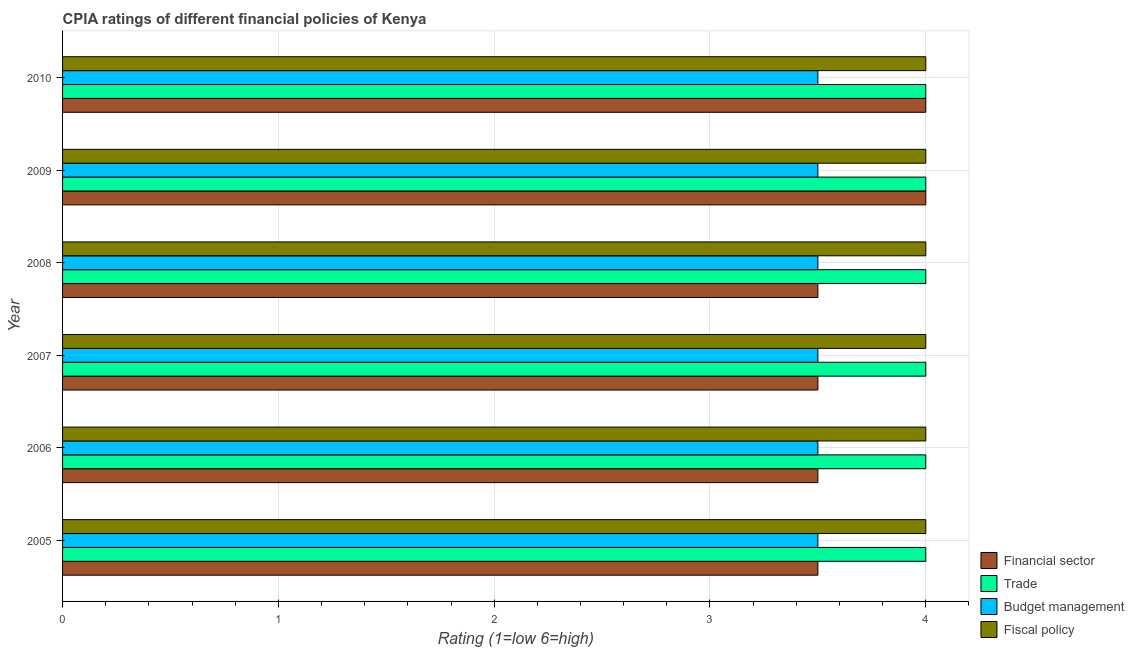How many different coloured bars are there?
Give a very brief answer. 4. Are the number of bars per tick equal to the number of legend labels?
Offer a terse response. Yes. Are the number of bars on each tick of the Y-axis equal?
Your response must be concise. Yes. In how many cases, is the number of bars for a given year not equal to the number of legend labels?
Ensure brevity in your answer.  0. What is the cpia rating of budget management in 2007?
Ensure brevity in your answer.  3.5. Across all years, what is the maximum cpia rating of trade?
Your answer should be compact. 4. Across all years, what is the minimum cpia rating of trade?
Your answer should be compact. 4. In which year was the cpia rating of fiscal policy maximum?
Give a very brief answer. 2005. In which year was the cpia rating of financial sector minimum?
Your response must be concise. 2005. What is the average cpia rating of financial sector per year?
Your answer should be compact. 3.67. What is the difference between the highest and the lowest cpia rating of trade?
Your response must be concise. 0. Is the sum of the cpia rating of budget management in 2005 and 2010 greater than the maximum cpia rating of financial sector across all years?
Offer a terse response. Yes. Is it the case that in every year, the sum of the cpia rating of trade and cpia rating of financial sector is greater than the sum of cpia rating of budget management and cpia rating of fiscal policy?
Provide a short and direct response. Yes. What does the 2nd bar from the top in 2005 represents?
Ensure brevity in your answer.  Budget management. What does the 1st bar from the bottom in 2005 represents?
Your answer should be very brief. Financial sector. Is it the case that in every year, the sum of the cpia rating of financial sector and cpia rating of trade is greater than the cpia rating of budget management?
Your answer should be very brief. Yes. How many bars are there?
Offer a terse response. 24. Are all the bars in the graph horizontal?
Ensure brevity in your answer.  Yes. What is the difference between two consecutive major ticks on the X-axis?
Offer a very short reply. 1. Does the graph contain grids?
Your response must be concise. Yes. How are the legend labels stacked?
Your answer should be very brief. Vertical. What is the title of the graph?
Provide a short and direct response. CPIA ratings of different financial policies of Kenya. Does "Building human resources" appear as one of the legend labels in the graph?
Make the answer very short. No. What is the Rating (1=low 6=high) in Financial sector in 2005?
Provide a succinct answer. 3.5. What is the Rating (1=low 6=high) in Fiscal policy in 2005?
Keep it short and to the point. 4. What is the Rating (1=low 6=high) of Financial sector in 2006?
Your answer should be compact. 3.5. What is the Rating (1=low 6=high) of Trade in 2006?
Provide a short and direct response. 4. What is the Rating (1=low 6=high) of Financial sector in 2007?
Keep it short and to the point. 3.5. What is the Rating (1=low 6=high) of Trade in 2007?
Offer a very short reply. 4. What is the Rating (1=low 6=high) in Budget management in 2007?
Keep it short and to the point. 3.5. What is the Rating (1=low 6=high) in Budget management in 2008?
Give a very brief answer. 3.5. What is the Rating (1=low 6=high) in Fiscal policy in 2008?
Make the answer very short. 4. What is the Rating (1=low 6=high) in Financial sector in 2009?
Provide a succinct answer. 4. What is the Rating (1=low 6=high) in Trade in 2009?
Provide a succinct answer. 4. What is the Rating (1=low 6=high) in Trade in 2010?
Keep it short and to the point. 4. What is the Rating (1=low 6=high) of Fiscal policy in 2010?
Your answer should be very brief. 4. Across all years, what is the maximum Rating (1=low 6=high) in Financial sector?
Provide a succinct answer. 4. Across all years, what is the maximum Rating (1=low 6=high) in Trade?
Ensure brevity in your answer.  4. Across all years, what is the minimum Rating (1=low 6=high) of Trade?
Offer a terse response. 4. What is the total Rating (1=low 6=high) of Financial sector in the graph?
Offer a very short reply. 22. What is the total Rating (1=low 6=high) of Trade in the graph?
Your response must be concise. 24. What is the total Rating (1=low 6=high) in Fiscal policy in the graph?
Make the answer very short. 24. What is the difference between the Rating (1=low 6=high) of Financial sector in 2005 and that in 2006?
Your response must be concise. 0. What is the difference between the Rating (1=low 6=high) of Financial sector in 2005 and that in 2007?
Offer a very short reply. 0. What is the difference between the Rating (1=low 6=high) of Trade in 2005 and that in 2007?
Make the answer very short. 0. What is the difference between the Rating (1=low 6=high) in Budget management in 2005 and that in 2007?
Your response must be concise. 0. What is the difference between the Rating (1=low 6=high) of Fiscal policy in 2005 and that in 2007?
Provide a short and direct response. 0. What is the difference between the Rating (1=low 6=high) in Budget management in 2005 and that in 2008?
Your answer should be very brief. 0. What is the difference between the Rating (1=low 6=high) of Fiscal policy in 2005 and that in 2008?
Give a very brief answer. 0. What is the difference between the Rating (1=low 6=high) of Financial sector in 2005 and that in 2009?
Give a very brief answer. -0.5. What is the difference between the Rating (1=low 6=high) in Trade in 2005 and that in 2009?
Give a very brief answer. 0. What is the difference between the Rating (1=low 6=high) of Fiscal policy in 2005 and that in 2009?
Ensure brevity in your answer.  0. What is the difference between the Rating (1=low 6=high) in Financial sector in 2005 and that in 2010?
Make the answer very short. -0.5. What is the difference between the Rating (1=low 6=high) in Fiscal policy in 2005 and that in 2010?
Offer a very short reply. 0. What is the difference between the Rating (1=low 6=high) in Trade in 2006 and that in 2007?
Your answer should be very brief. 0. What is the difference between the Rating (1=low 6=high) in Budget management in 2006 and that in 2007?
Offer a terse response. 0. What is the difference between the Rating (1=low 6=high) in Fiscal policy in 2006 and that in 2007?
Offer a very short reply. 0. What is the difference between the Rating (1=low 6=high) in Financial sector in 2006 and that in 2008?
Give a very brief answer. 0. What is the difference between the Rating (1=low 6=high) of Fiscal policy in 2006 and that in 2008?
Offer a terse response. 0. What is the difference between the Rating (1=low 6=high) of Financial sector in 2006 and that in 2009?
Ensure brevity in your answer.  -0.5. What is the difference between the Rating (1=low 6=high) of Trade in 2006 and that in 2009?
Provide a succinct answer. 0. What is the difference between the Rating (1=low 6=high) in Financial sector in 2006 and that in 2010?
Your answer should be compact. -0.5. What is the difference between the Rating (1=low 6=high) in Financial sector in 2007 and that in 2008?
Keep it short and to the point. 0. What is the difference between the Rating (1=low 6=high) of Trade in 2007 and that in 2008?
Make the answer very short. 0. What is the difference between the Rating (1=low 6=high) of Budget management in 2007 and that in 2008?
Make the answer very short. 0. What is the difference between the Rating (1=low 6=high) of Fiscal policy in 2007 and that in 2008?
Make the answer very short. 0. What is the difference between the Rating (1=low 6=high) in Financial sector in 2007 and that in 2009?
Ensure brevity in your answer.  -0.5. What is the difference between the Rating (1=low 6=high) of Fiscal policy in 2007 and that in 2009?
Make the answer very short. 0. What is the difference between the Rating (1=low 6=high) in Trade in 2007 and that in 2010?
Your answer should be very brief. 0. What is the difference between the Rating (1=low 6=high) in Budget management in 2007 and that in 2010?
Give a very brief answer. 0. What is the difference between the Rating (1=low 6=high) of Financial sector in 2008 and that in 2009?
Your answer should be compact. -0.5. What is the difference between the Rating (1=low 6=high) in Trade in 2008 and that in 2009?
Give a very brief answer. 0. What is the difference between the Rating (1=low 6=high) in Fiscal policy in 2008 and that in 2009?
Ensure brevity in your answer.  0. What is the difference between the Rating (1=low 6=high) in Financial sector in 2008 and that in 2010?
Provide a succinct answer. -0.5. What is the difference between the Rating (1=low 6=high) of Trade in 2008 and that in 2010?
Keep it short and to the point. 0. What is the difference between the Rating (1=low 6=high) of Budget management in 2008 and that in 2010?
Ensure brevity in your answer.  0. What is the difference between the Rating (1=low 6=high) in Trade in 2009 and that in 2010?
Offer a terse response. 0. What is the difference between the Rating (1=low 6=high) of Budget management in 2009 and that in 2010?
Offer a terse response. 0. What is the difference between the Rating (1=low 6=high) in Financial sector in 2005 and the Rating (1=low 6=high) in Trade in 2006?
Ensure brevity in your answer.  -0.5. What is the difference between the Rating (1=low 6=high) of Financial sector in 2005 and the Rating (1=low 6=high) of Budget management in 2006?
Ensure brevity in your answer.  0. What is the difference between the Rating (1=low 6=high) of Trade in 2005 and the Rating (1=low 6=high) of Budget management in 2006?
Provide a succinct answer. 0.5. What is the difference between the Rating (1=low 6=high) of Trade in 2005 and the Rating (1=low 6=high) of Fiscal policy in 2006?
Your response must be concise. 0. What is the difference between the Rating (1=low 6=high) in Financial sector in 2005 and the Rating (1=low 6=high) in Budget management in 2007?
Give a very brief answer. 0. What is the difference between the Rating (1=low 6=high) of Financial sector in 2005 and the Rating (1=low 6=high) of Fiscal policy in 2007?
Your answer should be compact. -0.5. What is the difference between the Rating (1=low 6=high) in Trade in 2005 and the Rating (1=low 6=high) in Budget management in 2007?
Give a very brief answer. 0.5. What is the difference between the Rating (1=low 6=high) of Financial sector in 2005 and the Rating (1=low 6=high) of Fiscal policy in 2008?
Your answer should be very brief. -0.5. What is the difference between the Rating (1=low 6=high) of Trade in 2005 and the Rating (1=low 6=high) of Fiscal policy in 2008?
Your answer should be very brief. 0. What is the difference between the Rating (1=low 6=high) of Financial sector in 2005 and the Rating (1=low 6=high) of Fiscal policy in 2009?
Keep it short and to the point. -0.5. What is the difference between the Rating (1=low 6=high) of Trade in 2005 and the Rating (1=low 6=high) of Budget management in 2009?
Make the answer very short. 0.5. What is the difference between the Rating (1=low 6=high) of Budget management in 2005 and the Rating (1=low 6=high) of Fiscal policy in 2009?
Give a very brief answer. -0.5. What is the difference between the Rating (1=low 6=high) in Trade in 2005 and the Rating (1=low 6=high) in Fiscal policy in 2010?
Offer a very short reply. 0. What is the difference between the Rating (1=low 6=high) of Budget management in 2005 and the Rating (1=low 6=high) of Fiscal policy in 2010?
Your answer should be very brief. -0.5. What is the difference between the Rating (1=low 6=high) in Financial sector in 2006 and the Rating (1=low 6=high) in Trade in 2007?
Ensure brevity in your answer.  -0.5. What is the difference between the Rating (1=low 6=high) of Financial sector in 2006 and the Rating (1=low 6=high) of Budget management in 2007?
Offer a very short reply. 0. What is the difference between the Rating (1=low 6=high) of Trade in 2006 and the Rating (1=low 6=high) of Budget management in 2007?
Your response must be concise. 0.5. What is the difference between the Rating (1=low 6=high) of Financial sector in 2006 and the Rating (1=low 6=high) of Trade in 2008?
Keep it short and to the point. -0.5. What is the difference between the Rating (1=low 6=high) of Financial sector in 2006 and the Rating (1=low 6=high) of Fiscal policy in 2008?
Make the answer very short. -0.5. What is the difference between the Rating (1=low 6=high) in Trade in 2006 and the Rating (1=low 6=high) in Fiscal policy in 2008?
Your answer should be very brief. 0. What is the difference between the Rating (1=low 6=high) of Budget management in 2006 and the Rating (1=low 6=high) of Fiscal policy in 2008?
Your response must be concise. -0.5. What is the difference between the Rating (1=low 6=high) of Financial sector in 2006 and the Rating (1=low 6=high) of Trade in 2009?
Your answer should be compact. -0.5. What is the difference between the Rating (1=low 6=high) in Financial sector in 2006 and the Rating (1=low 6=high) in Budget management in 2009?
Ensure brevity in your answer.  0. What is the difference between the Rating (1=low 6=high) of Trade in 2006 and the Rating (1=low 6=high) of Budget management in 2009?
Your answer should be compact. 0.5. What is the difference between the Rating (1=low 6=high) in Trade in 2006 and the Rating (1=low 6=high) in Fiscal policy in 2009?
Your answer should be compact. 0. What is the difference between the Rating (1=low 6=high) of Financial sector in 2006 and the Rating (1=low 6=high) of Budget management in 2010?
Your answer should be compact. 0. What is the difference between the Rating (1=low 6=high) in Financial sector in 2006 and the Rating (1=low 6=high) in Fiscal policy in 2010?
Your answer should be very brief. -0.5. What is the difference between the Rating (1=low 6=high) of Trade in 2006 and the Rating (1=low 6=high) of Budget management in 2010?
Give a very brief answer. 0.5. What is the difference between the Rating (1=low 6=high) of Budget management in 2006 and the Rating (1=low 6=high) of Fiscal policy in 2010?
Your response must be concise. -0.5. What is the difference between the Rating (1=low 6=high) in Trade in 2007 and the Rating (1=low 6=high) in Fiscal policy in 2008?
Your answer should be compact. 0. What is the difference between the Rating (1=low 6=high) in Financial sector in 2007 and the Rating (1=low 6=high) in Trade in 2009?
Your answer should be compact. -0.5. What is the difference between the Rating (1=low 6=high) in Trade in 2007 and the Rating (1=low 6=high) in Fiscal policy in 2009?
Provide a succinct answer. 0. What is the difference between the Rating (1=low 6=high) in Financial sector in 2007 and the Rating (1=low 6=high) in Trade in 2010?
Ensure brevity in your answer.  -0.5. What is the difference between the Rating (1=low 6=high) of Financial sector in 2008 and the Rating (1=low 6=high) of Trade in 2009?
Your answer should be compact. -0.5. What is the difference between the Rating (1=low 6=high) of Financial sector in 2008 and the Rating (1=low 6=high) of Budget management in 2009?
Your answer should be compact. 0. What is the difference between the Rating (1=low 6=high) in Financial sector in 2008 and the Rating (1=low 6=high) in Fiscal policy in 2009?
Keep it short and to the point. -0.5. What is the difference between the Rating (1=low 6=high) of Trade in 2008 and the Rating (1=low 6=high) of Budget management in 2009?
Your response must be concise. 0.5. What is the difference between the Rating (1=low 6=high) in Budget management in 2008 and the Rating (1=low 6=high) in Fiscal policy in 2009?
Offer a very short reply. -0.5. What is the difference between the Rating (1=low 6=high) of Financial sector in 2008 and the Rating (1=low 6=high) of Budget management in 2010?
Your answer should be very brief. 0. What is the difference between the Rating (1=low 6=high) of Financial sector in 2008 and the Rating (1=low 6=high) of Fiscal policy in 2010?
Your response must be concise. -0.5. What is the difference between the Rating (1=low 6=high) in Trade in 2008 and the Rating (1=low 6=high) in Fiscal policy in 2010?
Ensure brevity in your answer.  0. What is the difference between the Rating (1=low 6=high) of Budget management in 2008 and the Rating (1=low 6=high) of Fiscal policy in 2010?
Your answer should be very brief. -0.5. What is the difference between the Rating (1=low 6=high) in Financial sector in 2009 and the Rating (1=low 6=high) in Trade in 2010?
Your answer should be very brief. 0. What is the difference between the Rating (1=low 6=high) in Financial sector in 2009 and the Rating (1=low 6=high) in Budget management in 2010?
Keep it short and to the point. 0.5. What is the difference between the Rating (1=low 6=high) of Trade in 2009 and the Rating (1=low 6=high) of Fiscal policy in 2010?
Offer a terse response. 0. What is the difference between the Rating (1=low 6=high) in Budget management in 2009 and the Rating (1=low 6=high) in Fiscal policy in 2010?
Your answer should be very brief. -0.5. What is the average Rating (1=low 6=high) in Financial sector per year?
Your answer should be very brief. 3.67. What is the average Rating (1=low 6=high) of Trade per year?
Offer a terse response. 4. What is the average Rating (1=low 6=high) in Budget management per year?
Your answer should be compact. 3.5. In the year 2005, what is the difference between the Rating (1=low 6=high) of Financial sector and Rating (1=low 6=high) of Trade?
Provide a short and direct response. -0.5. In the year 2005, what is the difference between the Rating (1=low 6=high) of Financial sector and Rating (1=low 6=high) of Budget management?
Provide a succinct answer. 0. In the year 2005, what is the difference between the Rating (1=low 6=high) of Trade and Rating (1=low 6=high) of Fiscal policy?
Make the answer very short. 0. In the year 2006, what is the difference between the Rating (1=low 6=high) of Financial sector and Rating (1=low 6=high) of Budget management?
Offer a terse response. 0. In the year 2006, what is the difference between the Rating (1=low 6=high) in Financial sector and Rating (1=low 6=high) in Fiscal policy?
Provide a short and direct response. -0.5. In the year 2006, what is the difference between the Rating (1=low 6=high) of Budget management and Rating (1=low 6=high) of Fiscal policy?
Provide a short and direct response. -0.5. In the year 2007, what is the difference between the Rating (1=low 6=high) in Financial sector and Rating (1=low 6=high) in Trade?
Make the answer very short. -0.5. In the year 2008, what is the difference between the Rating (1=low 6=high) of Financial sector and Rating (1=low 6=high) of Trade?
Offer a terse response. -0.5. In the year 2008, what is the difference between the Rating (1=low 6=high) in Financial sector and Rating (1=low 6=high) in Budget management?
Give a very brief answer. 0. In the year 2008, what is the difference between the Rating (1=low 6=high) of Financial sector and Rating (1=low 6=high) of Fiscal policy?
Your answer should be very brief. -0.5. In the year 2008, what is the difference between the Rating (1=low 6=high) of Trade and Rating (1=low 6=high) of Budget management?
Ensure brevity in your answer.  0.5. In the year 2009, what is the difference between the Rating (1=low 6=high) in Financial sector and Rating (1=low 6=high) in Trade?
Provide a succinct answer. 0. In the year 2009, what is the difference between the Rating (1=low 6=high) in Budget management and Rating (1=low 6=high) in Fiscal policy?
Offer a very short reply. -0.5. In the year 2010, what is the difference between the Rating (1=low 6=high) of Financial sector and Rating (1=low 6=high) of Budget management?
Provide a short and direct response. 0.5. What is the ratio of the Rating (1=low 6=high) of Financial sector in 2005 to that in 2006?
Make the answer very short. 1. What is the ratio of the Rating (1=low 6=high) in Budget management in 2005 to that in 2006?
Make the answer very short. 1. What is the ratio of the Rating (1=low 6=high) of Financial sector in 2005 to that in 2007?
Offer a very short reply. 1. What is the ratio of the Rating (1=low 6=high) in Trade in 2005 to that in 2007?
Your answer should be very brief. 1. What is the ratio of the Rating (1=low 6=high) of Financial sector in 2005 to that in 2008?
Offer a terse response. 1. What is the ratio of the Rating (1=low 6=high) of Trade in 2005 to that in 2008?
Make the answer very short. 1. What is the ratio of the Rating (1=low 6=high) in Budget management in 2005 to that in 2009?
Keep it short and to the point. 1. What is the ratio of the Rating (1=low 6=high) in Fiscal policy in 2005 to that in 2009?
Keep it short and to the point. 1. What is the ratio of the Rating (1=low 6=high) in Trade in 2005 to that in 2010?
Offer a very short reply. 1. What is the ratio of the Rating (1=low 6=high) in Budget management in 2005 to that in 2010?
Give a very brief answer. 1. What is the ratio of the Rating (1=low 6=high) of Fiscal policy in 2005 to that in 2010?
Provide a succinct answer. 1. What is the ratio of the Rating (1=low 6=high) in Trade in 2006 to that in 2008?
Your answer should be compact. 1. What is the ratio of the Rating (1=low 6=high) of Budget management in 2006 to that in 2008?
Your answer should be very brief. 1. What is the ratio of the Rating (1=low 6=high) of Fiscal policy in 2006 to that in 2008?
Make the answer very short. 1. What is the ratio of the Rating (1=low 6=high) in Financial sector in 2006 to that in 2009?
Offer a terse response. 0.88. What is the ratio of the Rating (1=low 6=high) of Budget management in 2006 to that in 2009?
Keep it short and to the point. 1. What is the ratio of the Rating (1=low 6=high) in Financial sector in 2006 to that in 2010?
Your answer should be compact. 0.88. What is the ratio of the Rating (1=low 6=high) in Trade in 2006 to that in 2010?
Keep it short and to the point. 1. What is the ratio of the Rating (1=low 6=high) of Budget management in 2006 to that in 2010?
Your answer should be very brief. 1. What is the ratio of the Rating (1=low 6=high) in Financial sector in 2007 to that in 2008?
Your answer should be very brief. 1. What is the ratio of the Rating (1=low 6=high) in Trade in 2007 to that in 2008?
Offer a terse response. 1. What is the ratio of the Rating (1=low 6=high) of Budget management in 2007 to that in 2008?
Your answer should be very brief. 1. What is the ratio of the Rating (1=low 6=high) in Fiscal policy in 2007 to that in 2009?
Your answer should be compact. 1. What is the ratio of the Rating (1=low 6=high) in Financial sector in 2007 to that in 2010?
Your response must be concise. 0.88. What is the ratio of the Rating (1=low 6=high) of Trade in 2007 to that in 2010?
Keep it short and to the point. 1. What is the ratio of the Rating (1=low 6=high) in Budget management in 2007 to that in 2010?
Offer a terse response. 1. What is the ratio of the Rating (1=low 6=high) in Financial sector in 2008 to that in 2009?
Provide a succinct answer. 0.88. What is the ratio of the Rating (1=low 6=high) in Budget management in 2008 to that in 2009?
Make the answer very short. 1. What is the ratio of the Rating (1=low 6=high) in Financial sector in 2009 to that in 2010?
Offer a terse response. 1. What is the ratio of the Rating (1=low 6=high) in Trade in 2009 to that in 2010?
Keep it short and to the point. 1. What is the ratio of the Rating (1=low 6=high) in Fiscal policy in 2009 to that in 2010?
Give a very brief answer. 1. What is the difference between the highest and the second highest Rating (1=low 6=high) of Financial sector?
Make the answer very short. 0. What is the difference between the highest and the second highest Rating (1=low 6=high) in Trade?
Give a very brief answer. 0. What is the difference between the highest and the lowest Rating (1=low 6=high) of Financial sector?
Keep it short and to the point. 0.5. What is the difference between the highest and the lowest Rating (1=low 6=high) of Budget management?
Your answer should be compact. 0. 